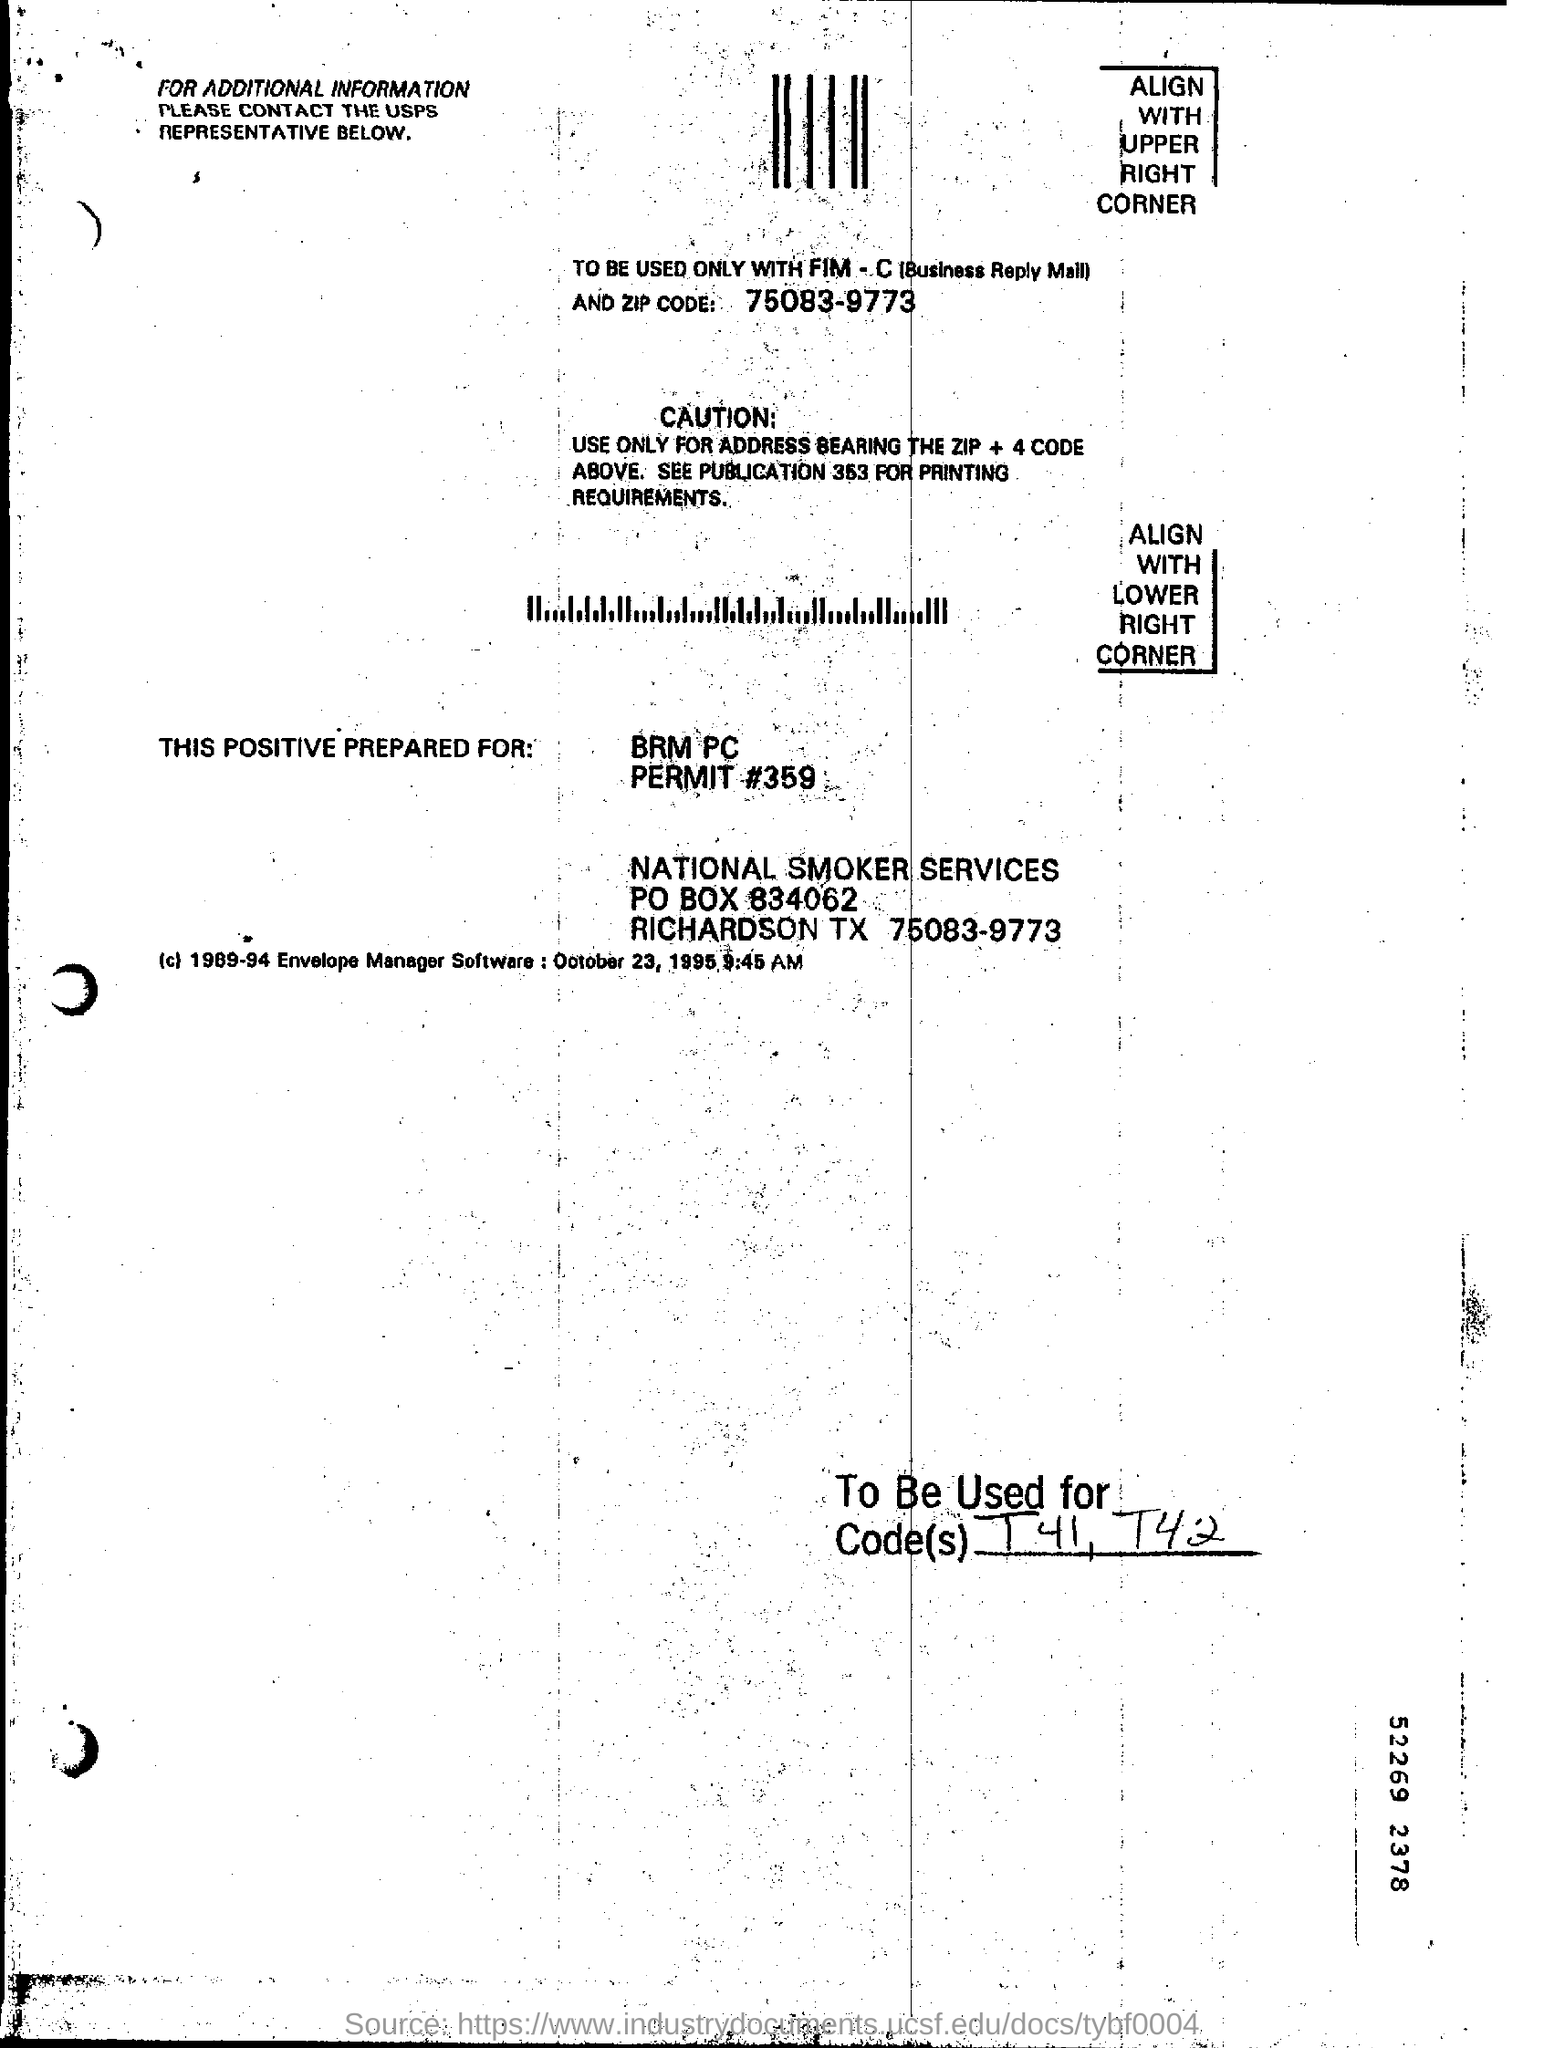Give some essential details in this illustration. The zip code mentioned is 75083-9773. It is recommended that addresses with a zip code plus 4 should be used. The question "what is the permit#?" is a request for information about a permit, specifically the number "359. 